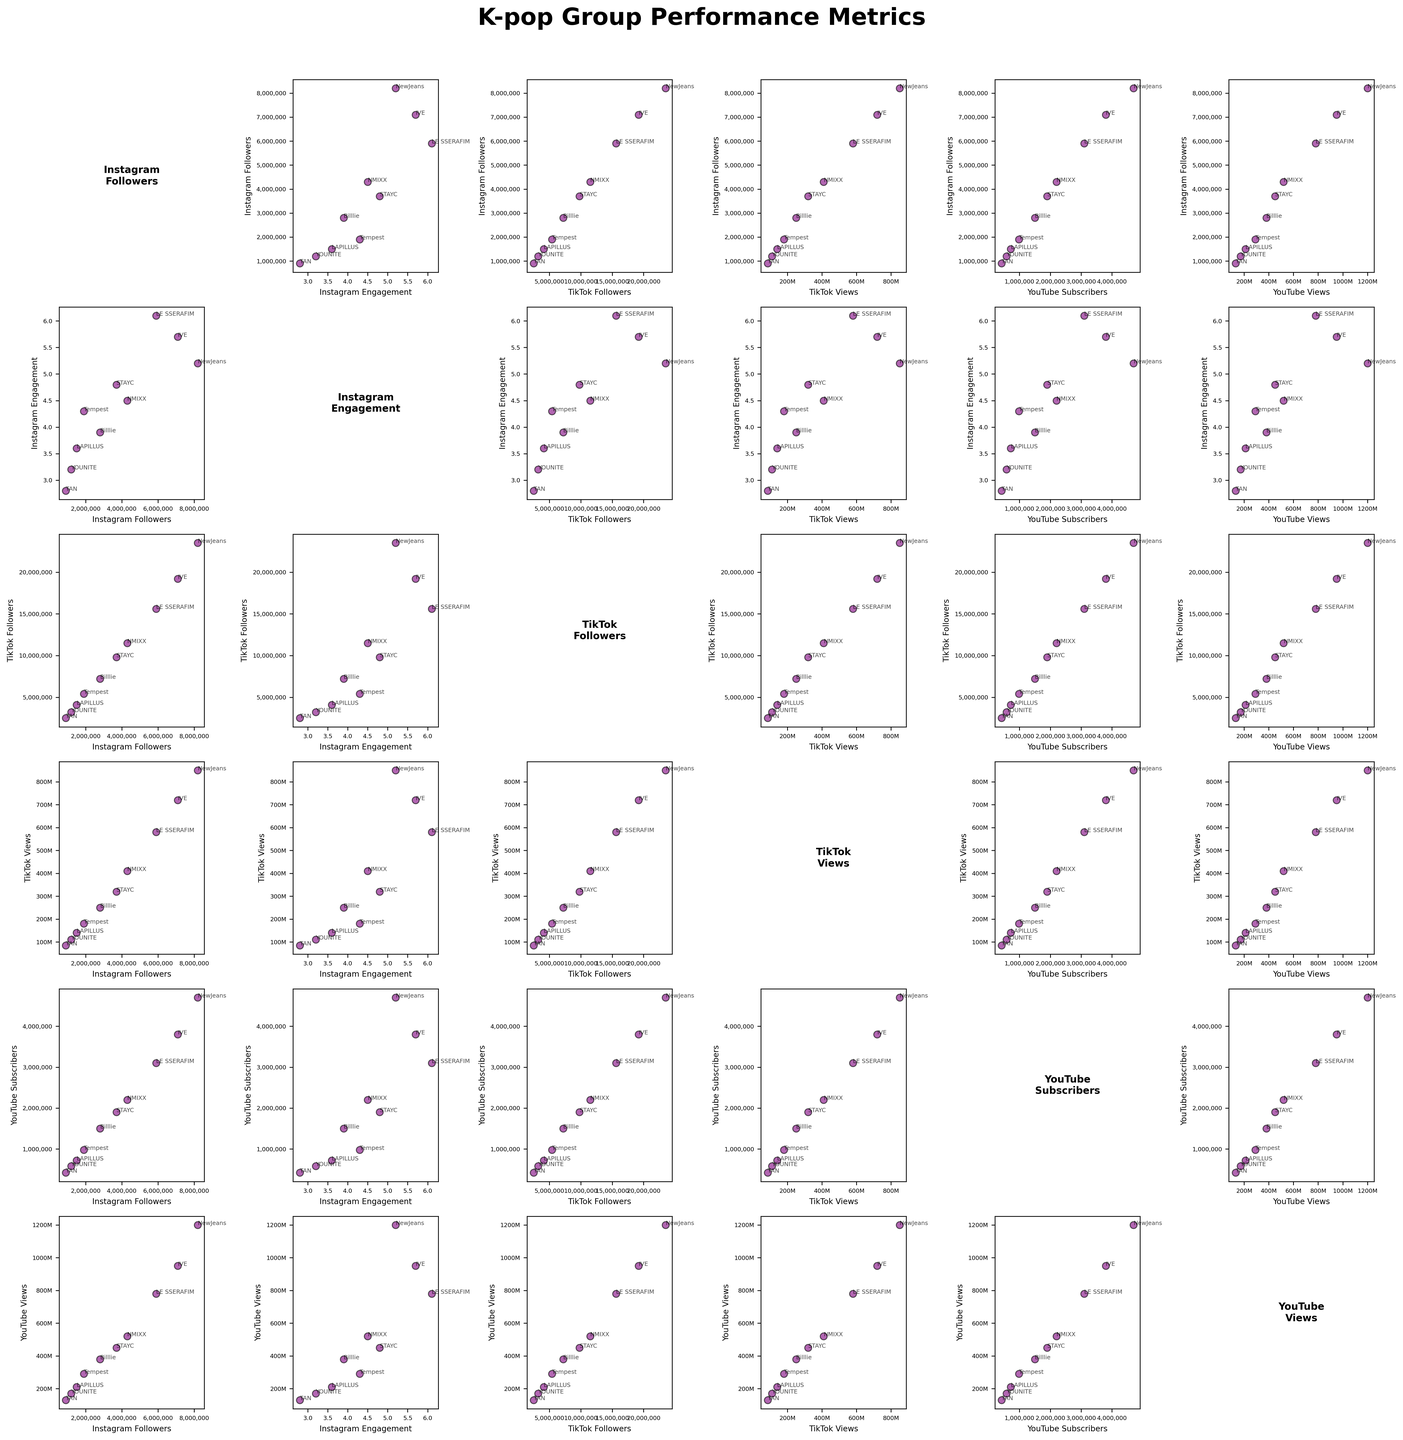What is the title of the plot? The title of the plot is displayed at the top center of the figure, with the text "K-pop Group Performance Metrics" in bold.
Answer: K-pop Group Performance Metrics How many different performance metrics are displayed in the scatterplot matrix? The scatterplot matrix consists of six numeric columns, each representing a different performance metric such as 'Instagram Followers', 'Instagram Engagement', 'TikTok Followers', 'TikTok Views', 'YouTube Subscribers', and 'YouTube Views'.
Answer: 6 Which group has the highest number of Instagram Followers? By looking at the scatter plots involving 'Instagram Followers', the data points with the highest values on the x-axis or y-axis are for NewJeans at 8,200,000 followers.
Answer: NewJeans Which two groups have similar YouTube Subscribers? By examining the scatter plots and annotations for 'YouTube Subscribers', LE SSERAFIM and IVE have similar counts, both in the range of around 3,000,000 to 3,800,000.
Answer: LE SSERAFIM and IVE What is the relationship between TikTok Followers and TikTok Views for NewJeans? Observing the scatter plots where 'TikTok Followers' and 'TikTok Views' intersect, NewJeans is annotated at the highest point in terms of both metrics, with 23,500,000 followers leading to 850,000,000 views.
Answer: Higher TikTok Followers lead to higher TikTok Views Which metric shows the weakest correlation with Instagram Engagement? By visually inspecting the scatter plots where 'Instagram Engagement' appears, TikTok Followers or TikTok Views show the least-defined clustering or trend, hinting at a weaker correlation.
Answer: TikTok Followers/TikTok Views How do the groups with the highest YouTube Views compare in terms of Instagram Engagement? By examining the scatter plots involving 'YouTube Views' and locating the highest annotations (NewJeans and IVE), then cross-referencing those with 'Instagram Engagement', NewJeans has higher engagement (5.2%) compared to IVE (5.7%).
Answer: NewJeans has higher engagement What general trend do you observe between YouTube Subscribers and YouTube Views? By observing the relevant scatter plots, there is a positive correlation where groups with higher YouTube Subscribers consistently have higher YouTube Views.
Answer: Positive correlation What are the metrics for LAPILLUS in terms of Instagram Followers and YouTube Subscribers? By finding LAPILLUS's annotation on the axes of 'Instagram Followers' and 'YouTube Subscribers', the group has 1,500,000 Instagram Followers and 720,000 YouTube Subscribers.
Answer: 1,500,000 Instagram Followers, 720,000 YouTube Subscribers 